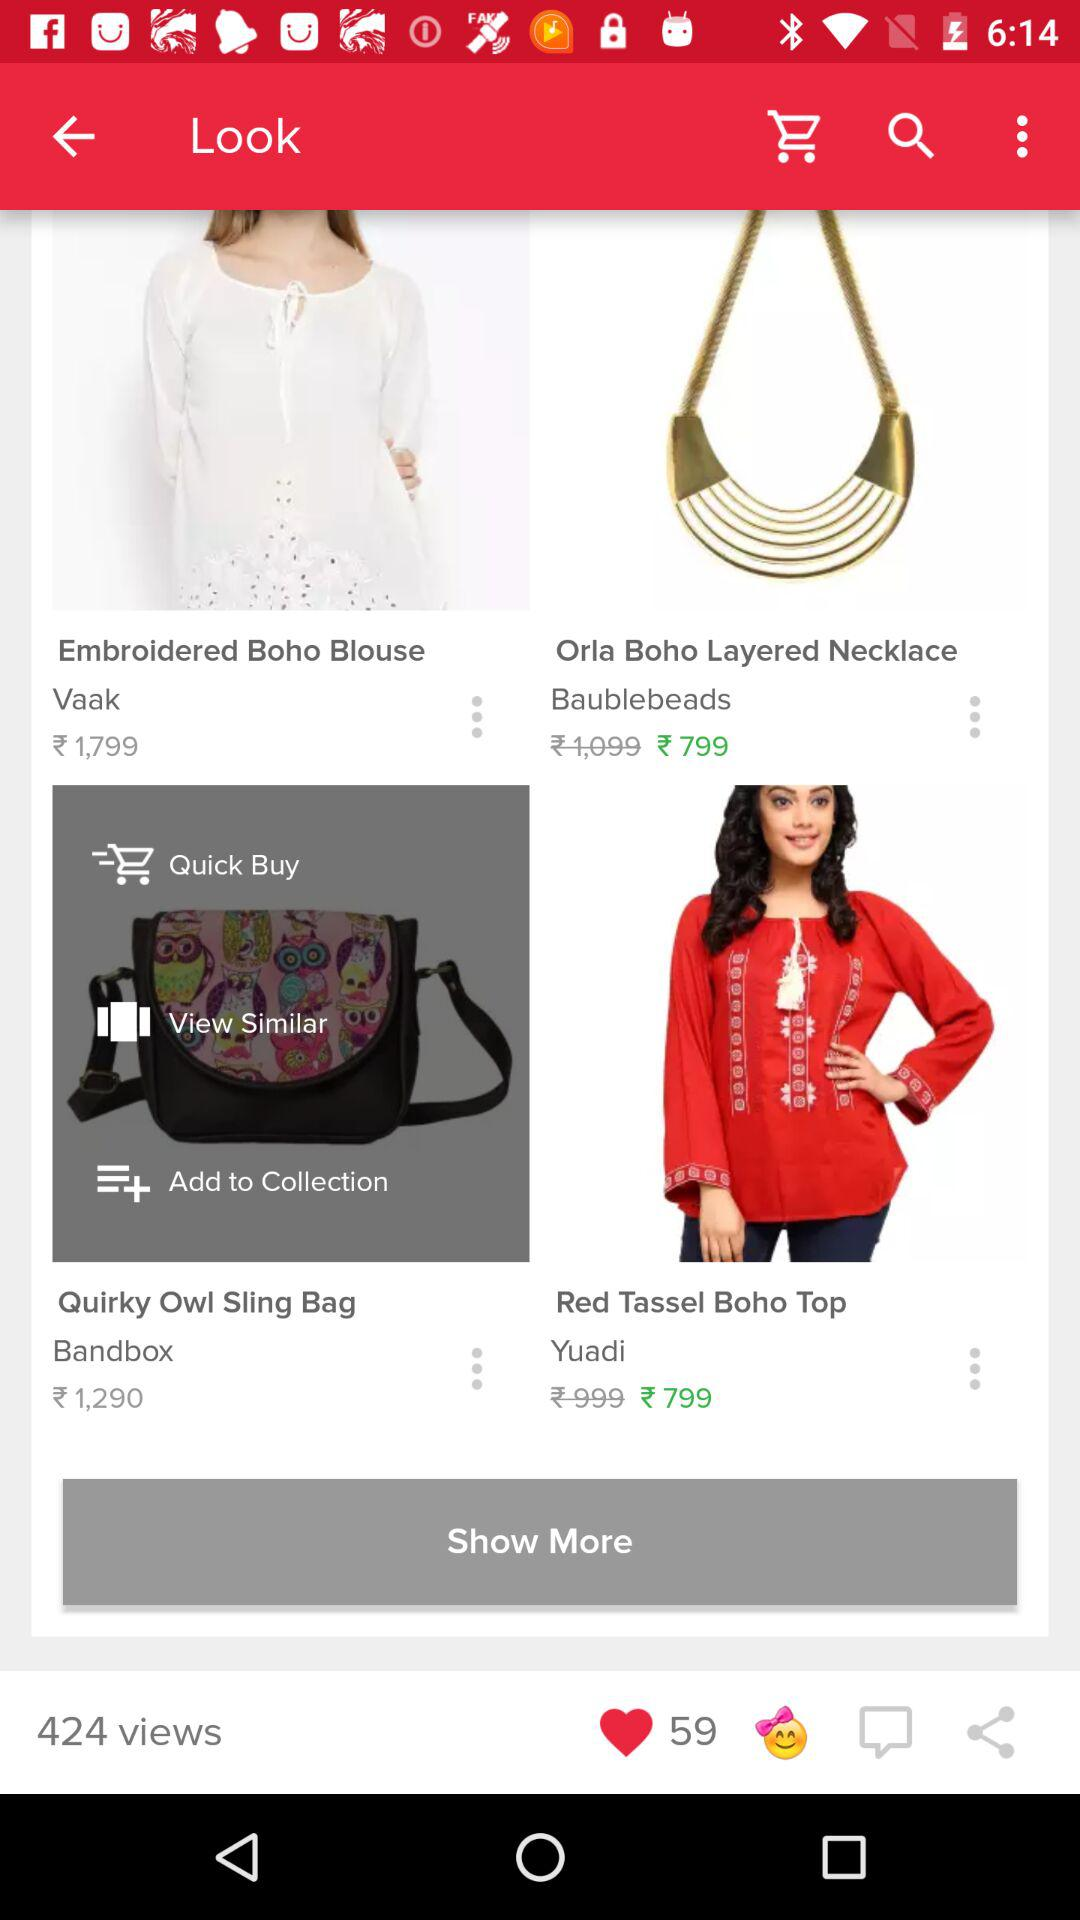What is the price of "Red Boho Top"? The price of "Red Boho Top" is ₹799. 